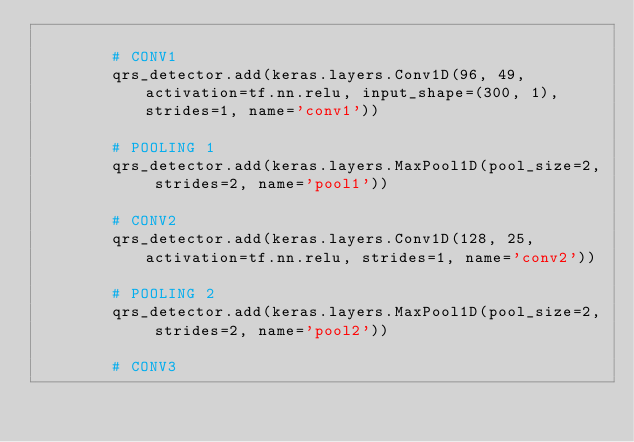<code> <loc_0><loc_0><loc_500><loc_500><_Python_>
        # CONV1
        qrs_detector.add(keras.layers.Conv1D(96, 49, activation=tf.nn.relu, input_shape=(300, 1), strides=1, name='conv1'))

        # POOLING 1
        qrs_detector.add(keras.layers.MaxPool1D(pool_size=2, strides=2, name='pool1'))

        # CONV2
        qrs_detector.add(keras.layers.Conv1D(128, 25, activation=tf.nn.relu, strides=1, name='conv2'))

        # POOLING 2
        qrs_detector.add(keras.layers.MaxPool1D(pool_size=2, strides=2, name='pool2'))

        # CONV3</code> 